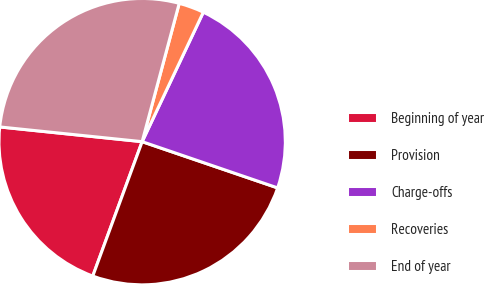<chart> <loc_0><loc_0><loc_500><loc_500><pie_chart><fcel>Beginning of year<fcel>Provision<fcel>Charge-offs<fcel>Recoveries<fcel>End of year<nl><fcel>21.04%<fcel>25.37%<fcel>23.21%<fcel>2.86%<fcel>27.53%<nl></chart> 